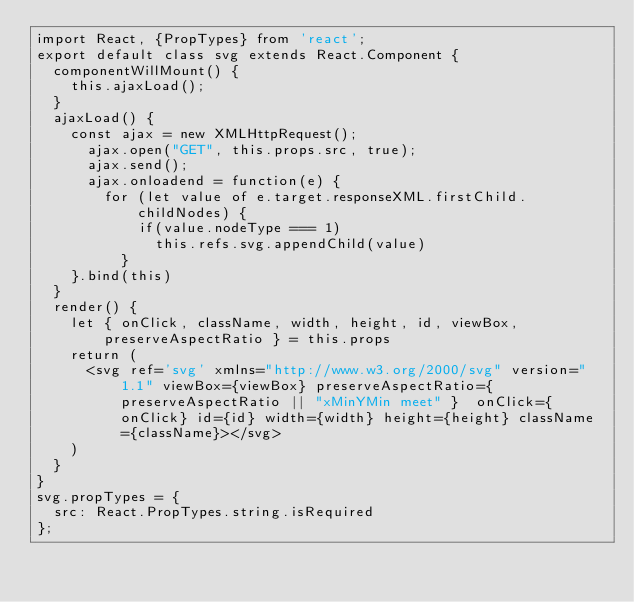Convert code to text. <code><loc_0><loc_0><loc_500><loc_500><_JavaScript_>import React, {PropTypes} from 'react';
export default class svg extends React.Component {
  componentWillMount() {
    this.ajaxLoad();
  }
  ajaxLoad() {
    const ajax = new XMLHttpRequest();
      ajax.open("GET", this.props.src, true);
      ajax.send();
      ajax.onloadend = function(e) {
        for (let value of e.target.responseXML.firstChild.childNodes) {
            if(value.nodeType === 1)
              this.refs.svg.appendChild(value)
          }
    }.bind(this)
  }
  render() {
    let { onClick, className, width, height, id, viewBox, preserveAspectRatio } = this.props
    return (
      <svg ref='svg' xmlns="http://www.w3.org/2000/svg" version="1.1" viewBox={viewBox} preserveAspectRatio={preserveAspectRatio || "xMinYMin meet" }  onClick={onClick} id={id} width={width} height={height} className={className}></svg>
    )
  }
}
svg.propTypes = {
  src: React.PropTypes.string.isRequired
};
</code> 